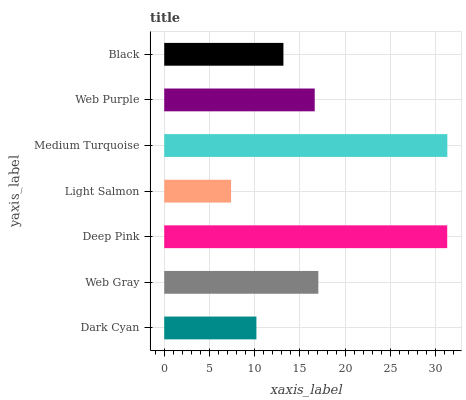Is Light Salmon the minimum?
Answer yes or no. Yes. Is Medium Turquoise the maximum?
Answer yes or no. Yes. Is Web Gray the minimum?
Answer yes or no. No. Is Web Gray the maximum?
Answer yes or no. No. Is Web Gray greater than Dark Cyan?
Answer yes or no. Yes. Is Dark Cyan less than Web Gray?
Answer yes or no. Yes. Is Dark Cyan greater than Web Gray?
Answer yes or no. No. Is Web Gray less than Dark Cyan?
Answer yes or no. No. Is Web Purple the high median?
Answer yes or no. Yes. Is Web Purple the low median?
Answer yes or no. Yes. Is Deep Pink the high median?
Answer yes or no. No. Is Deep Pink the low median?
Answer yes or no. No. 